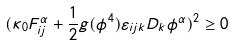<formula> <loc_0><loc_0><loc_500><loc_500>( \kappa _ { 0 } F _ { i j } ^ { \alpha } + \frac { 1 } { 2 } g ( \phi ^ { 4 } ) \varepsilon _ { i j k } D _ { k } \phi ^ { \alpha } ) ^ { 2 } \geq 0</formula> 